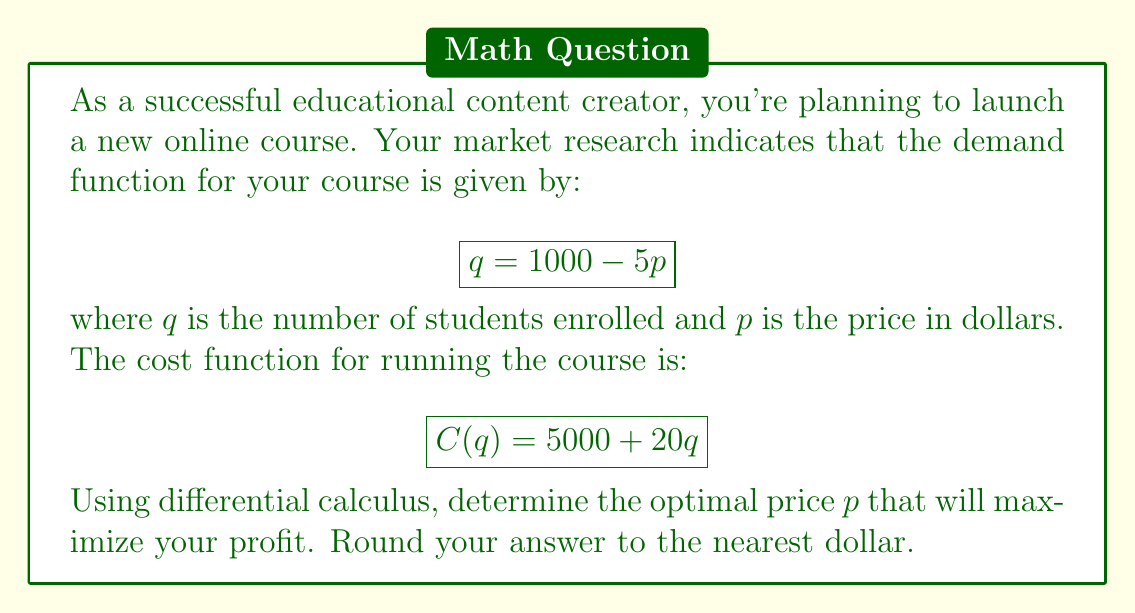Help me with this question. Let's approach this step-by-step:

1) First, we need to express the profit function in terms of p. Profit is revenue minus cost:

   $$\text{Profit} = \text{Revenue} - \text{Cost}$$

2) Revenue is price times quantity: $R = pq$
   Cost is given as: $C(q) = 5000 + 20q$

3) Substituting the demand function $q = 1000 - 5p$ into these:

   $$\text{Revenue} = p(1000 - 5p) = 1000p - 5p^2$$
   $$\text{Cost} = 5000 + 20(1000 - 5p) = 25000 - 100p$$

4) Now we can express profit as a function of p:

   $$\text{Profit}(p) = (1000p - 5p^2) - (25000 - 100p)$$
   $$\text{Profit}(p) = 1100p - 5p^2 - 25000$$

5) To maximize profit, we find where the derivative of the profit function equals zero:

   $$\frac{d}{dp}[\text{Profit}(p)] = 1100 - 10p$$

6) Set this equal to zero and solve for p:

   $$1100 - 10p = 0$$
   $$-10p = -1100$$
   $$p = 110$$

7) To confirm this is a maximum, we can check the second derivative:

   $$\frac{d^2}{dp^2}[\text{Profit}(p)] = -10$$

   Since this is negative, we confirm that $p = 110$ gives a maximum.

8) Rounding to the nearest dollar, our optimal price is $110.
Answer: $110 